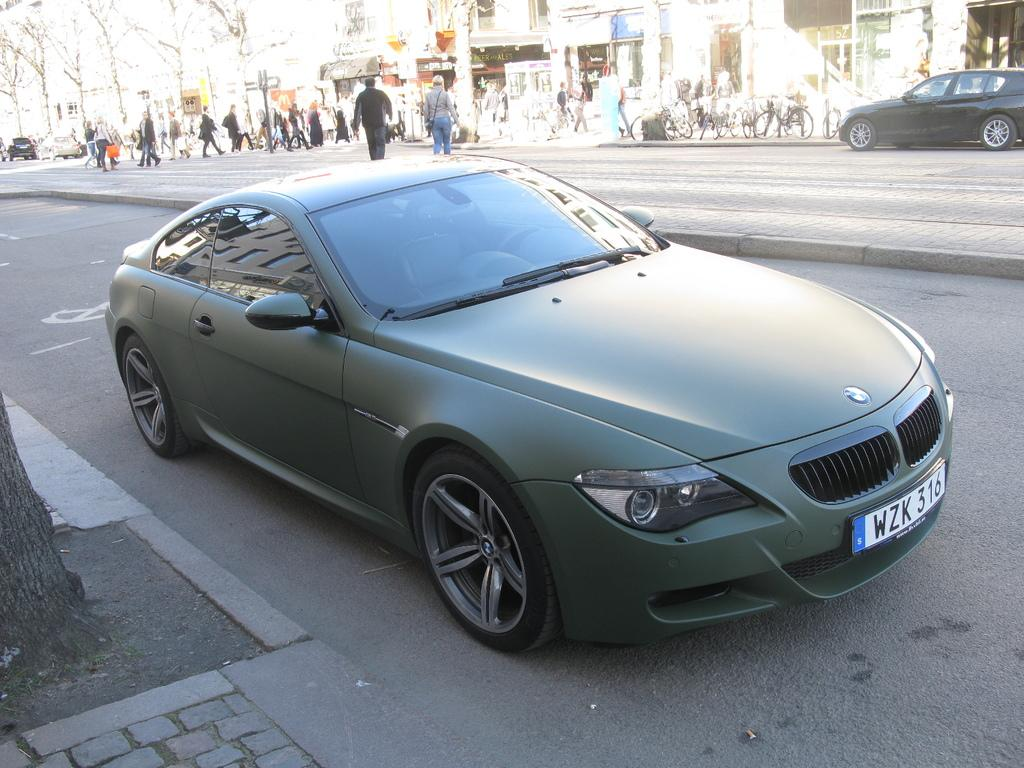What is happening on the road in the image? There are vehicles on a road in the image, and people are crossing the road. What are the people in the image doing besides crossing the road? There are people walking on a footpath in the image. What can be seen in the background of the image? There are trees, buildings, and cycles in the background of the image. What type of sack is being used by the people walking on the footpath in the image? There is no sack visible in the image; people are walking without any sacks. What hobbies do the people in the image have while they are sleeping? There is no indication of people sleeping in the image, and their hobbies cannot be determined from the image. 